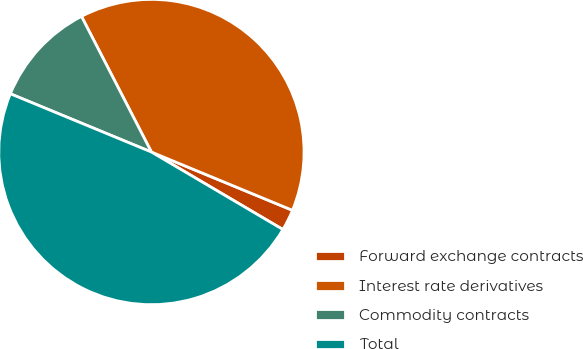Convert chart to OTSL. <chart><loc_0><loc_0><loc_500><loc_500><pie_chart><fcel>Forward exchange contracts<fcel>Interest rate derivatives<fcel>Commodity contracts<fcel>Total<nl><fcel>2.24%<fcel>38.81%<fcel>11.19%<fcel>47.76%<nl></chart> 